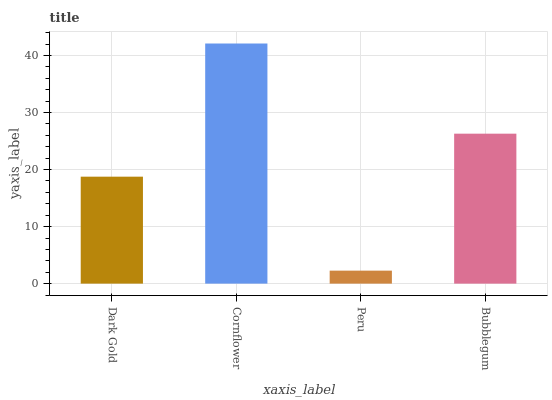Is Peru the minimum?
Answer yes or no. Yes. Is Cornflower the maximum?
Answer yes or no. Yes. Is Cornflower the minimum?
Answer yes or no. No. Is Peru the maximum?
Answer yes or no. No. Is Cornflower greater than Peru?
Answer yes or no. Yes. Is Peru less than Cornflower?
Answer yes or no. Yes. Is Peru greater than Cornflower?
Answer yes or no. No. Is Cornflower less than Peru?
Answer yes or no. No. Is Bubblegum the high median?
Answer yes or no. Yes. Is Dark Gold the low median?
Answer yes or no. Yes. Is Dark Gold the high median?
Answer yes or no. No. Is Peru the low median?
Answer yes or no. No. 